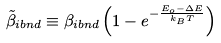Convert formula to latex. <formula><loc_0><loc_0><loc_500><loc_500>\tilde { \beta } _ { i b n d } \equiv \beta _ { i b n d } \left ( 1 - e ^ { - \frac { E _ { o } - \Delta E } { k _ { B } T } } \right )</formula> 